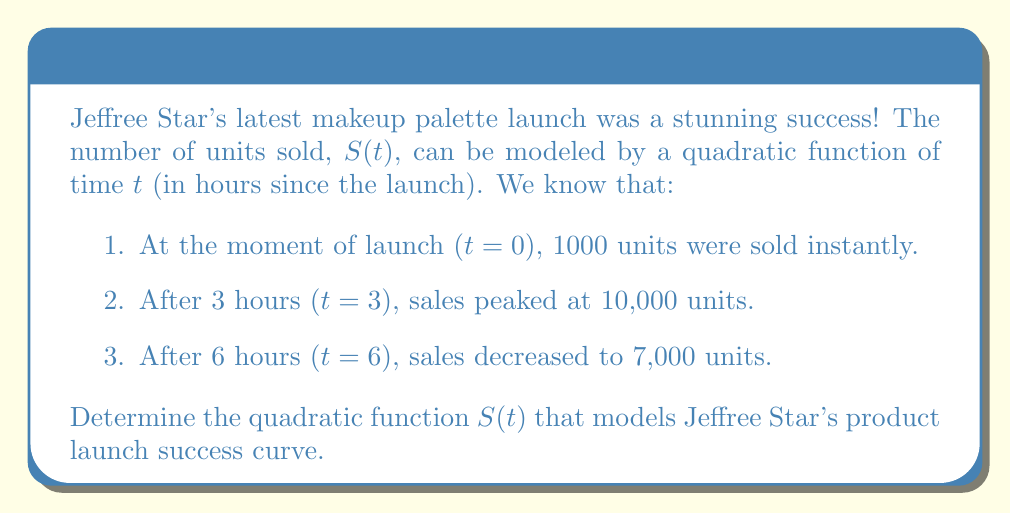Solve this math problem. Let's approach this step-by-step, using the general form of a quadratic function: $S(t) = at^2 + bt + c$

1) We know that when $t=0$, $S(0) = 1000$. This gives us our first equation:
   $c = 1000$

2) We can now use the other two points to create two more equations:
   For $t=3$: $S(3) = 9a + 3b + 1000 = 10000$
   For $t=6$: $S(6) = 36a + 6b + 1000 = 7000$

3) Subtracting the second equation from the third:
   $27a + 3b = -3000$
   $9a + b = -1000$ ... (Equation 1)

4) From the $t=3$ equation:
   $9a + 3b = 9000$
   $3a + b = 3000$ ... (Equation 2)

5) Subtracting Equation 1 from Equation 2:
   $-6a = 4000$
   $a = -\frac{2000}{3}$

6) Substituting this value of $a$ back into Equation 1:
   $9(-\frac{2000}{3}) + b = -1000$
   $-6000 + b = -1000$
   $b = 5000$

7) Now we have all our coefficients:
   $a = -\frac{2000}{3}$
   $b = 5000$
   $c = 1000$

Therefore, the quadratic function modeling Jeffree Star's product launch success curve is:

$$S(t) = -\frac{2000}{3}t^2 + 5000t + 1000$$
Answer: $S(t) = -\frac{2000}{3}t^2 + 5000t + 1000$ 